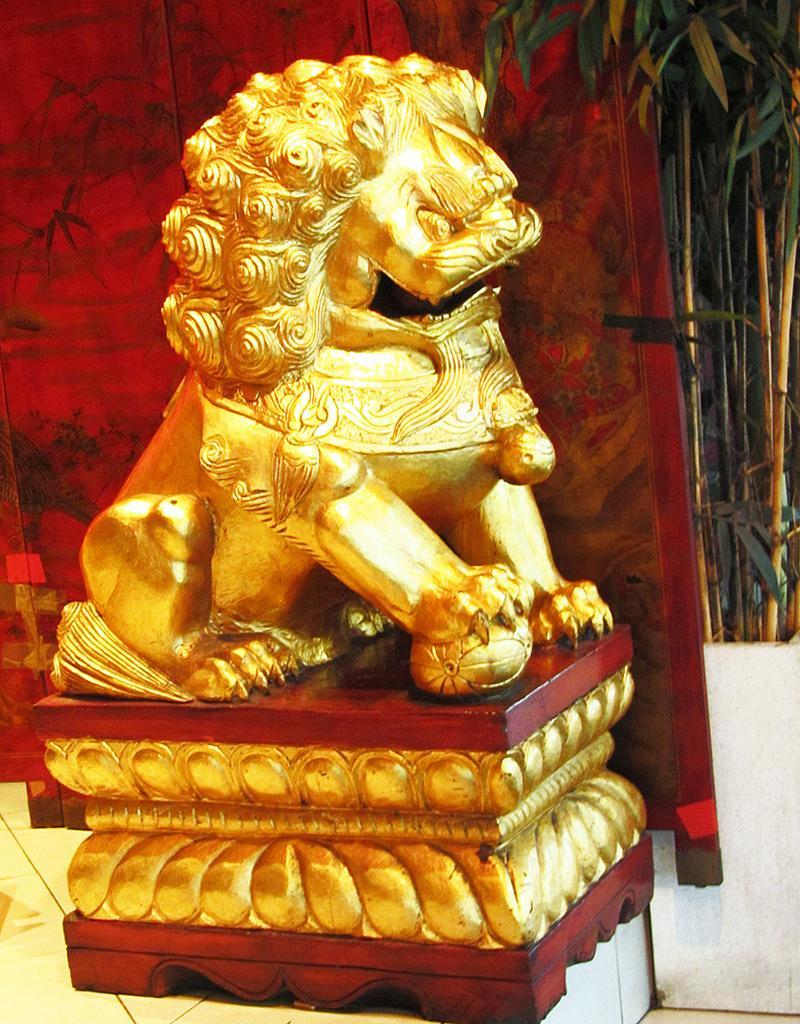Can you describe this image briefly? In this picture in the middle, we can see a statue of a lion. In the background, there is painting, flower pot and plants. 